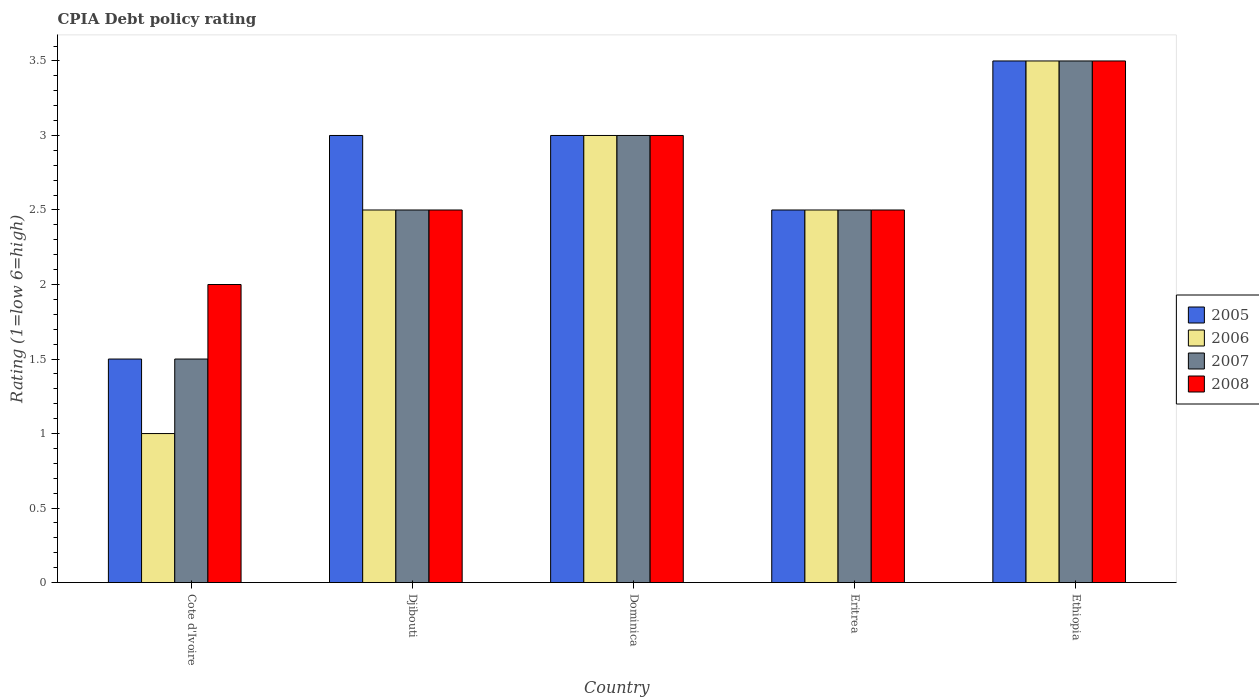How many groups of bars are there?
Your answer should be compact. 5. Are the number of bars on each tick of the X-axis equal?
Offer a terse response. Yes. What is the label of the 4th group of bars from the left?
Keep it short and to the point. Eritrea. In how many cases, is the number of bars for a given country not equal to the number of legend labels?
Provide a succinct answer. 0. What is the CPIA rating in 2007 in Djibouti?
Give a very brief answer. 2.5. In which country was the CPIA rating in 2008 maximum?
Your answer should be very brief. Ethiopia. In which country was the CPIA rating in 2006 minimum?
Ensure brevity in your answer.  Cote d'Ivoire. What is the difference between the CPIA rating in 2008 in Cote d'Ivoire and that in Eritrea?
Your answer should be very brief. -0.5. What is the difference between the CPIA rating in 2006 in Dominica and the CPIA rating in 2005 in Cote d'Ivoire?
Provide a succinct answer. 1.5. In how many countries, is the CPIA rating in 2008 greater than 0.6?
Provide a short and direct response. 5. What is the ratio of the CPIA rating in 2005 in Cote d'Ivoire to that in Djibouti?
Provide a succinct answer. 0.5. Is the difference between the CPIA rating in 2006 in Cote d'Ivoire and Djibouti greater than the difference between the CPIA rating in 2007 in Cote d'Ivoire and Djibouti?
Provide a succinct answer. No. What is the difference between the highest and the lowest CPIA rating in 2006?
Provide a short and direct response. 2.5. What does the 3rd bar from the right in Dominica represents?
Ensure brevity in your answer.  2006. Is it the case that in every country, the sum of the CPIA rating in 2005 and CPIA rating in 2006 is greater than the CPIA rating in 2007?
Your answer should be compact. Yes. Does the graph contain grids?
Ensure brevity in your answer.  No. How many legend labels are there?
Offer a terse response. 4. What is the title of the graph?
Make the answer very short. CPIA Debt policy rating. Does "2010" appear as one of the legend labels in the graph?
Offer a terse response. No. What is the label or title of the X-axis?
Ensure brevity in your answer.  Country. What is the Rating (1=low 6=high) of 2007 in Cote d'Ivoire?
Offer a very short reply. 1.5. What is the Rating (1=low 6=high) of 2008 in Cote d'Ivoire?
Your response must be concise. 2. What is the Rating (1=low 6=high) in 2005 in Djibouti?
Offer a terse response. 3. What is the Rating (1=low 6=high) of 2007 in Djibouti?
Your response must be concise. 2.5. What is the Rating (1=low 6=high) in 2008 in Djibouti?
Provide a short and direct response. 2.5. What is the Rating (1=low 6=high) of 2005 in Dominica?
Keep it short and to the point. 3. What is the Rating (1=low 6=high) in 2006 in Dominica?
Provide a short and direct response. 3. What is the Rating (1=low 6=high) of 2007 in Eritrea?
Provide a succinct answer. 2.5. Across all countries, what is the maximum Rating (1=low 6=high) in 2006?
Provide a short and direct response. 3.5. Across all countries, what is the maximum Rating (1=low 6=high) in 2007?
Make the answer very short. 3.5. Across all countries, what is the minimum Rating (1=low 6=high) in 2005?
Offer a very short reply. 1.5. Across all countries, what is the minimum Rating (1=low 6=high) of 2006?
Provide a short and direct response. 1. Across all countries, what is the minimum Rating (1=low 6=high) in 2008?
Provide a succinct answer. 2. What is the total Rating (1=low 6=high) of 2005 in the graph?
Provide a short and direct response. 13.5. What is the total Rating (1=low 6=high) of 2006 in the graph?
Your response must be concise. 12.5. What is the total Rating (1=low 6=high) of 2008 in the graph?
Your answer should be very brief. 13.5. What is the difference between the Rating (1=low 6=high) in 2007 in Cote d'Ivoire and that in Djibouti?
Ensure brevity in your answer.  -1. What is the difference between the Rating (1=low 6=high) of 2005 in Cote d'Ivoire and that in Dominica?
Your response must be concise. -1.5. What is the difference between the Rating (1=low 6=high) in 2006 in Cote d'Ivoire and that in Dominica?
Give a very brief answer. -2. What is the difference between the Rating (1=low 6=high) of 2005 in Cote d'Ivoire and that in Eritrea?
Ensure brevity in your answer.  -1. What is the difference between the Rating (1=low 6=high) of 2008 in Cote d'Ivoire and that in Eritrea?
Provide a succinct answer. -0.5. What is the difference between the Rating (1=low 6=high) in 2005 in Cote d'Ivoire and that in Ethiopia?
Give a very brief answer. -2. What is the difference between the Rating (1=low 6=high) in 2006 in Djibouti and that in Dominica?
Keep it short and to the point. -0.5. What is the difference between the Rating (1=low 6=high) in 2008 in Djibouti and that in Dominica?
Your answer should be very brief. -0.5. What is the difference between the Rating (1=low 6=high) in 2005 in Djibouti and that in Eritrea?
Your answer should be compact. 0.5. What is the difference between the Rating (1=low 6=high) in 2005 in Djibouti and that in Ethiopia?
Offer a terse response. -0.5. What is the difference between the Rating (1=low 6=high) of 2006 in Djibouti and that in Ethiopia?
Offer a very short reply. -1. What is the difference between the Rating (1=low 6=high) of 2006 in Dominica and that in Eritrea?
Give a very brief answer. 0.5. What is the difference between the Rating (1=low 6=high) in 2007 in Dominica and that in Eritrea?
Offer a terse response. 0.5. What is the difference between the Rating (1=low 6=high) of 2005 in Dominica and that in Ethiopia?
Provide a succinct answer. -0.5. What is the difference between the Rating (1=low 6=high) in 2006 in Dominica and that in Ethiopia?
Offer a terse response. -0.5. What is the difference between the Rating (1=low 6=high) of 2008 in Dominica and that in Ethiopia?
Make the answer very short. -0.5. What is the difference between the Rating (1=low 6=high) of 2005 in Eritrea and that in Ethiopia?
Give a very brief answer. -1. What is the difference between the Rating (1=low 6=high) of 2005 in Cote d'Ivoire and the Rating (1=low 6=high) of 2008 in Djibouti?
Your response must be concise. -1. What is the difference between the Rating (1=low 6=high) in 2007 in Cote d'Ivoire and the Rating (1=low 6=high) in 2008 in Djibouti?
Make the answer very short. -1. What is the difference between the Rating (1=low 6=high) in 2005 in Cote d'Ivoire and the Rating (1=low 6=high) in 2006 in Dominica?
Offer a very short reply. -1.5. What is the difference between the Rating (1=low 6=high) in 2005 in Cote d'Ivoire and the Rating (1=low 6=high) in 2007 in Dominica?
Keep it short and to the point. -1.5. What is the difference between the Rating (1=low 6=high) in 2006 in Cote d'Ivoire and the Rating (1=low 6=high) in 2008 in Dominica?
Provide a short and direct response. -2. What is the difference between the Rating (1=low 6=high) of 2005 in Cote d'Ivoire and the Rating (1=low 6=high) of 2006 in Eritrea?
Ensure brevity in your answer.  -1. What is the difference between the Rating (1=low 6=high) of 2006 in Cote d'Ivoire and the Rating (1=low 6=high) of 2007 in Eritrea?
Your answer should be compact. -1.5. What is the difference between the Rating (1=low 6=high) in 2007 in Cote d'Ivoire and the Rating (1=low 6=high) in 2008 in Eritrea?
Keep it short and to the point. -1. What is the difference between the Rating (1=low 6=high) of 2005 in Cote d'Ivoire and the Rating (1=low 6=high) of 2006 in Ethiopia?
Ensure brevity in your answer.  -2. What is the difference between the Rating (1=low 6=high) in 2005 in Cote d'Ivoire and the Rating (1=low 6=high) in 2007 in Ethiopia?
Your answer should be very brief. -2. What is the difference between the Rating (1=low 6=high) in 2005 in Cote d'Ivoire and the Rating (1=low 6=high) in 2008 in Ethiopia?
Provide a short and direct response. -2. What is the difference between the Rating (1=low 6=high) of 2006 in Cote d'Ivoire and the Rating (1=low 6=high) of 2008 in Ethiopia?
Keep it short and to the point. -2.5. What is the difference between the Rating (1=low 6=high) of 2007 in Djibouti and the Rating (1=low 6=high) of 2008 in Dominica?
Your response must be concise. -0.5. What is the difference between the Rating (1=low 6=high) of 2005 in Djibouti and the Rating (1=low 6=high) of 2006 in Eritrea?
Provide a short and direct response. 0.5. What is the difference between the Rating (1=low 6=high) in 2005 in Djibouti and the Rating (1=low 6=high) in 2008 in Eritrea?
Your response must be concise. 0.5. What is the difference between the Rating (1=low 6=high) of 2006 in Djibouti and the Rating (1=low 6=high) of 2007 in Eritrea?
Your response must be concise. 0. What is the difference between the Rating (1=low 6=high) of 2005 in Djibouti and the Rating (1=low 6=high) of 2006 in Ethiopia?
Ensure brevity in your answer.  -0.5. What is the difference between the Rating (1=low 6=high) in 2005 in Djibouti and the Rating (1=low 6=high) in 2007 in Ethiopia?
Offer a terse response. -0.5. What is the difference between the Rating (1=low 6=high) of 2005 in Djibouti and the Rating (1=low 6=high) of 2008 in Ethiopia?
Offer a terse response. -0.5. What is the difference between the Rating (1=low 6=high) of 2006 in Djibouti and the Rating (1=low 6=high) of 2007 in Ethiopia?
Ensure brevity in your answer.  -1. What is the difference between the Rating (1=low 6=high) in 2006 in Djibouti and the Rating (1=low 6=high) in 2008 in Ethiopia?
Offer a terse response. -1. What is the difference between the Rating (1=low 6=high) in 2005 in Dominica and the Rating (1=low 6=high) in 2007 in Eritrea?
Your answer should be very brief. 0.5. What is the difference between the Rating (1=low 6=high) of 2006 in Dominica and the Rating (1=low 6=high) of 2008 in Eritrea?
Make the answer very short. 0.5. What is the difference between the Rating (1=low 6=high) in 2005 in Dominica and the Rating (1=low 6=high) in 2006 in Ethiopia?
Ensure brevity in your answer.  -0.5. What is the difference between the Rating (1=low 6=high) in 2006 in Dominica and the Rating (1=low 6=high) in 2007 in Ethiopia?
Offer a terse response. -0.5. What is the difference between the Rating (1=low 6=high) of 2006 in Dominica and the Rating (1=low 6=high) of 2008 in Ethiopia?
Offer a terse response. -0.5. What is the difference between the Rating (1=low 6=high) of 2005 in Eritrea and the Rating (1=low 6=high) of 2006 in Ethiopia?
Provide a succinct answer. -1. What is the difference between the Rating (1=low 6=high) of 2005 in Eritrea and the Rating (1=low 6=high) of 2007 in Ethiopia?
Offer a very short reply. -1. What is the average Rating (1=low 6=high) in 2006 per country?
Ensure brevity in your answer.  2.5. What is the average Rating (1=low 6=high) of 2008 per country?
Offer a terse response. 2.7. What is the difference between the Rating (1=low 6=high) of 2007 and Rating (1=low 6=high) of 2008 in Cote d'Ivoire?
Offer a terse response. -0.5. What is the difference between the Rating (1=low 6=high) of 2005 and Rating (1=low 6=high) of 2007 in Djibouti?
Keep it short and to the point. 0.5. What is the difference between the Rating (1=low 6=high) in 2006 and Rating (1=low 6=high) in 2007 in Djibouti?
Give a very brief answer. 0. What is the difference between the Rating (1=low 6=high) of 2006 and Rating (1=low 6=high) of 2008 in Djibouti?
Offer a very short reply. 0. What is the difference between the Rating (1=low 6=high) in 2005 and Rating (1=low 6=high) in 2006 in Dominica?
Provide a short and direct response. 0. What is the difference between the Rating (1=low 6=high) of 2005 and Rating (1=low 6=high) of 2007 in Dominica?
Your answer should be compact. 0. What is the difference between the Rating (1=low 6=high) in 2006 and Rating (1=low 6=high) in 2007 in Dominica?
Offer a terse response. 0. What is the difference between the Rating (1=low 6=high) in 2006 and Rating (1=low 6=high) in 2008 in Dominica?
Give a very brief answer. 0. What is the difference between the Rating (1=low 6=high) in 2005 and Rating (1=low 6=high) in 2006 in Eritrea?
Your answer should be compact. 0. What is the difference between the Rating (1=low 6=high) of 2006 and Rating (1=low 6=high) of 2007 in Eritrea?
Make the answer very short. 0. What is the difference between the Rating (1=low 6=high) in 2007 and Rating (1=low 6=high) in 2008 in Eritrea?
Offer a terse response. 0. What is the difference between the Rating (1=low 6=high) of 2005 and Rating (1=low 6=high) of 2006 in Ethiopia?
Your response must be concise. 0. What is the difference between the Rating (1=low 6=high) of 2005 and Rating (1=low 6=high) of 2007 in Ethiopia?
Your answer should be compact. 0. What is the difference between the Rating (1=low 6=high) of 2005 and Rating (1=low 6=high) of 2008 in Ethiopia?
Your answer should be compact. 0. What is the difference between the Rating (1=low 6=high) of 2006 and Rating (1=low 6=high) of 2007 in Ethiopia?
Provide a short and direct response. 0. What is the difference between the Rating (1=low 6=high) of 2006 and Rating (1=low 6=high) of 2008 in Ethiopia?
Give a very brief answer. 0. What is the ratio of the Rating (1=low 6=high) of 2007 in Cote d'Ivoire to that in Djibouti?
Your answer should be compact. 0.6. What is the ratio of the Rating (1=low 6=high) of 2008 in Cote d'Ivoire to that in Djibouti?
Keep it short and to the point. 0.8. What is the ratio of the Rating (1=low 6=high) in 2005 in Cote d'Ivoire to that in Dominica?
Your answer should be compact. 0.5. What is the ratio of the Rating (1=low 6=high) in 2007 in Cote d'Ivoire to that in Dominica?
Offer a very short reply. 0.5. What is the ratio of the Rating (1=low 6=high) in 2008 in Cote d'Ivoire to that in Dominica?
Give a very brief answer. 0.67. What is the ratio of the Rating (1=low 6=high) of 2008 in Cote d'Ivoire to that in Eritrea?
Your answer should be compact. 0.8. What is the ratio of the Rating (1=low 6=high) of 2005 in Cote d'Ivoire to that in Ethiopia?
Your answer should be very brief. 0.43. What is the ratio of the Rating (1=low 6=high) of 2006 in Cote d'Ivoire to that in Ethiopia?
Offer a very short reply. 0.29. What is the ratio of the Rating (1=low 6=high) of 2007 in Cote d'Ivoire to that in Ethiopia?
Provide a short and direct response. 0.43. What is the ratio of the Rating (1=low 6=high) in 2008 in Djibouti to that in Dominica?
Ensure brevity in your answer.  0.83. What is the ratio of the Rating (1=low 6=high) of 2006 in Djibouti to that in Eritrea?
Provide a succinct answer. 1. What is the ratio of the Rating (1=low 6=high) of 2005 in Djibouti to that in Ethiopia?
Provide a short and direct response. 0.86. What is the ratio of the Rating (1=low 6=high) in 2006 in Djibouti to that in Ethiopia?
Your answer should be compact. 0.71. What is the ratio of the Rating (1=low 6=high) of 2008 in Djibouti to that in Ethiopia?
Give a very brief answer. 0.71. What is the ratio of the Rating (1=low 6=high) of 2006 in Dominica to that in Eritrea?
Provide a succinct answer. 1.2. What is the ratio of the Rating (1=low 6=high) of 2008 in Dominica to that in Eritrea?
Offer a very short reply. 1.2. What is the ratio of the Rating (1=low 6=high) in 2006 in Dominica to that in Ethiopia?
Offer a very short reply. 0.86. What is the ratio of the Rating (1=low 6=high) of 2007 in Dominica to that in Ethiopia?
Your answer should be very brief. 0.86. What is the ratio of the Rating (1=low 6=high) of 2008 in Eritrea to that in Ethiopia?
Make the answer very short. 0.71. What is the difference between the highest and the second highest Rating (1=low 6=high) in 2005?
Make the answer very short. 0.5. What is the difference between the highest and the second highest Rating (1=low 6=high) of 2006?
Your response must be concise. 0.5. What is the difference between the highest and the second highest Rating (1=low 6=high) of 2007?
Keep it short and to the point. 0.5. What is the difference between the highest and the second highest Rating (1=low 6=high) of 2008?
Keep it short and to the point. 0.5. What is the difference between the highest and the lowest Rating (1=low 6=high) of 2005?
Provide a succinct answer. 2. 